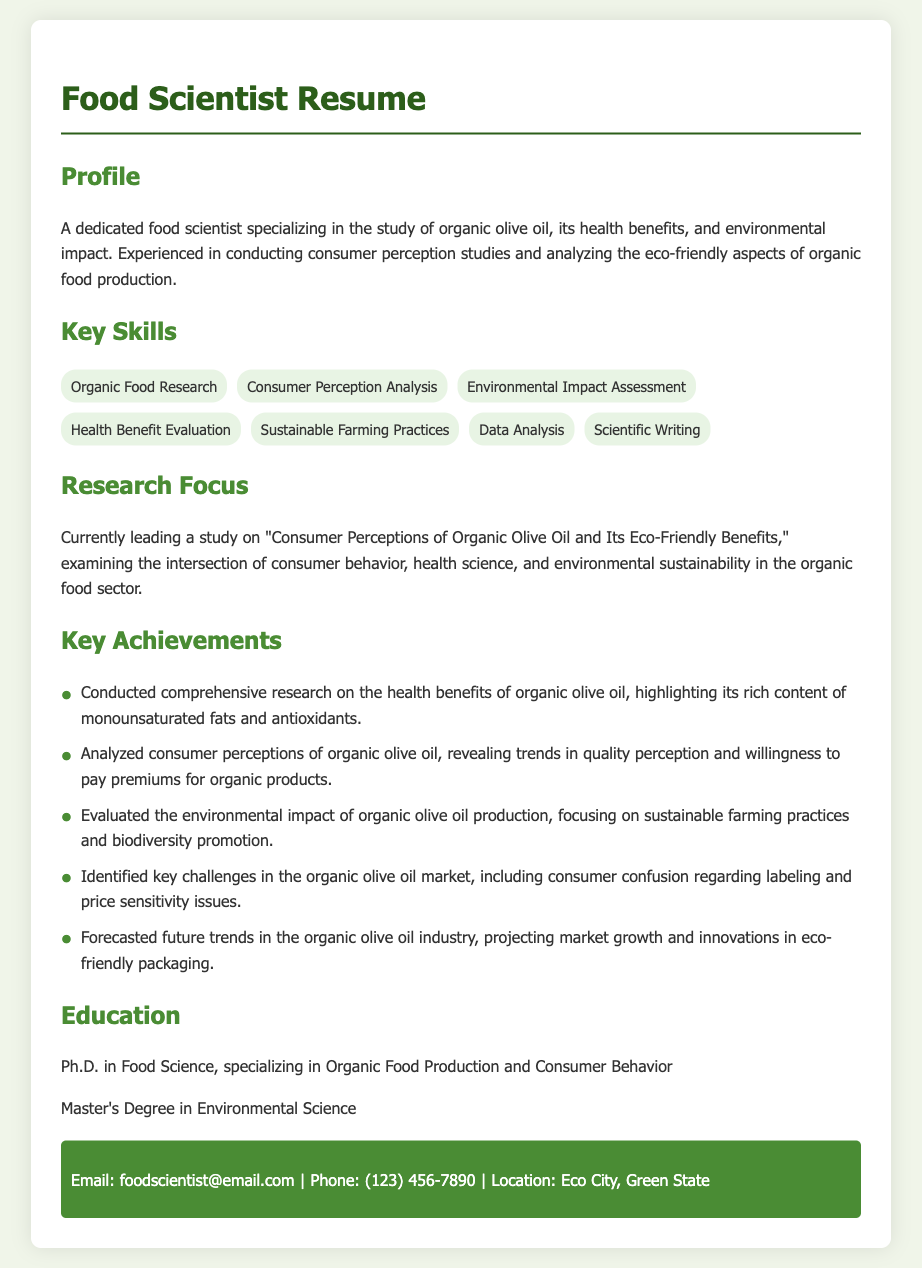What is the title of the presentation? The title of the presentation is explicitly stated in the document under the "Research Focus" section.
Answer: Consumer Perceptions of Organic Olive Oil and Its Eco-Friendly Benefits What is one key skill listed in the resume? The resume lists various skills; any one of them is valid.
Answer: Data Analysis What academic degree does the food scientist hold? The "Education" section mentions the degrees held by the food scientist.
Answer: Ph.D. in Food Science How many key achievements are listed in the resume? The achievements are numbered in the "Key Achievements" section.
Answer: Five What does the food scientist specialize in? The "Profile" section clearly outlines the specialization of the food scientist.
Answer: Organic olive oil What was one of the challenges identified in the organic olive oil market? The challenges are mentioned under the "Key Achievements" section, where obstacles in the market are highlighted.
Answer: Consumer confusion regarding labeling What is the email address of the food scientist? The contact information in the document contains this specific detail.
Answer: foodscientist@email.com What is the main focus of the research mentioned in the resume? The main focus is summarized in the "Research Focus" section.
Answer: Intersection of consumer behavior, health science, and environmental sustainability What color theme is primarily used in the document? The overall color scheme used in the document can be inferred from the style descriptions.
Answer: Green 